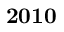Convert formula to latex. <formula><loc_0><loc_0><loc_500><loc_500>2 0 1 0</formula> 